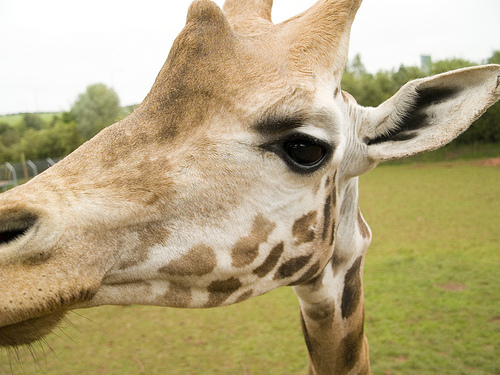<image>
Is the giraffe head on the green grass? No. The giraffe head is not positioned on the green grass. They may be near each other, but the giraffe head is not supported by or resting on top of the green grass. 